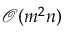Convert formula to latex. <formula><loc_0><loc_0><loc_500><loc_500>\mathcal { O } ( { m ^ { 2 } n } )</formula> 